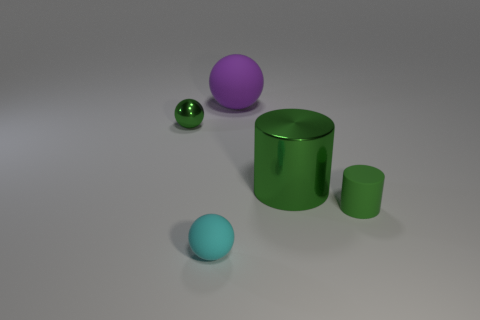Add 5 large shiny things. How many objects exist? 10 Subtract all cylinders. How many objects are left? 3 Subtract 0 cyan cylinders. How many objects are left? 5 Subtract all purple matte balls. Subtract all large purple things. How many objects are left? 3 Add 5 metallic spheres. How many metallic spheres are left? 6 Add 5 big metal cylinders. How many big metal cylinders exist? 6 